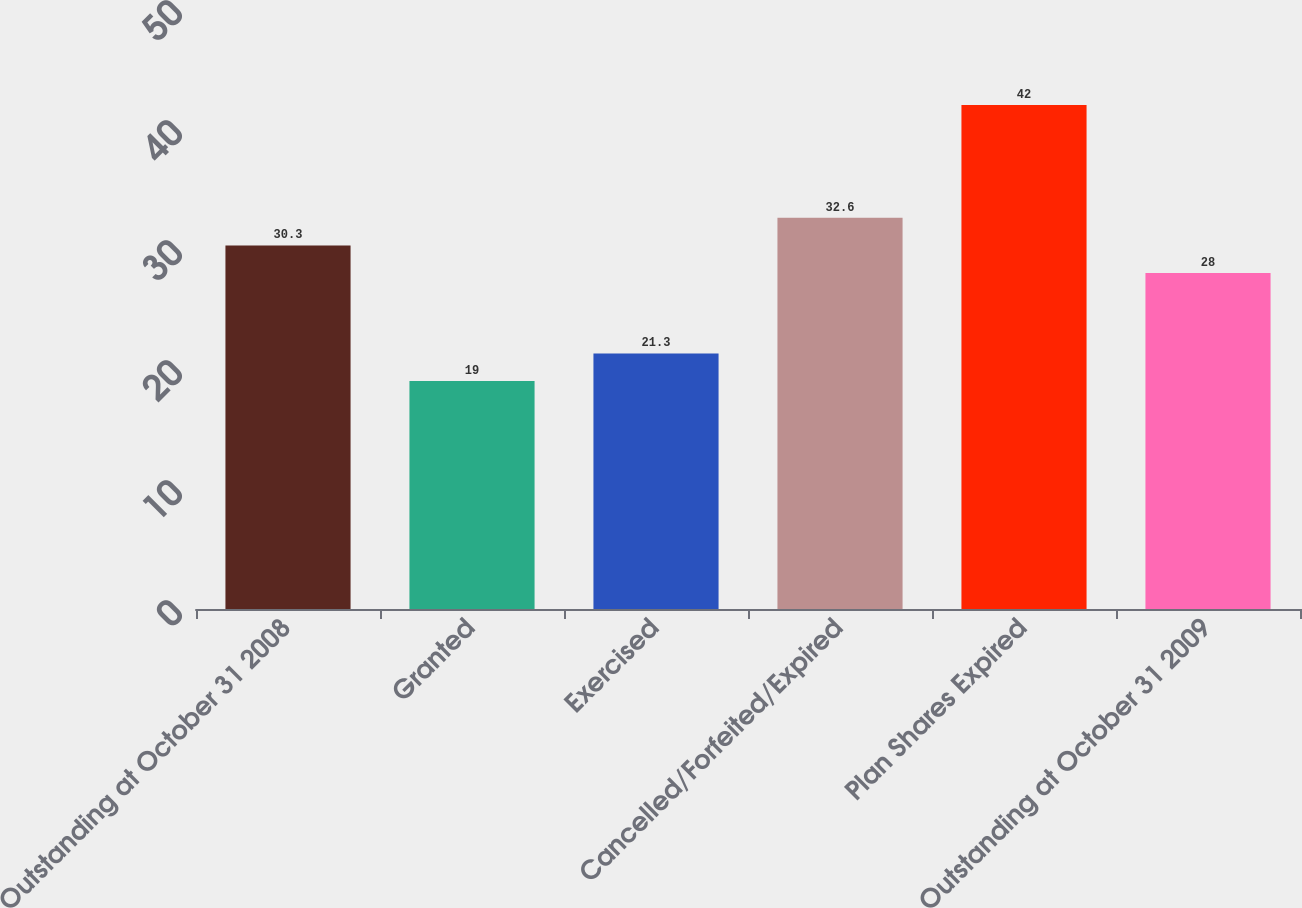Convert chart to OTSL. <chart><loc_0><loc_0><loc_500><loc_500><bar_chart><fcel>Outstanding at October 31 2008<fcel>Granted<fcel>Exercised<fcel>Cancelled/Forfeited/Expired<fcel>Plan Shares Expired<fcel>Outstanding at October 31 2009<nl><fcel>30.3<fcel>19<fcel>21.3<fcel>32.6<fcel>42<fcel>28<nl></chart> 